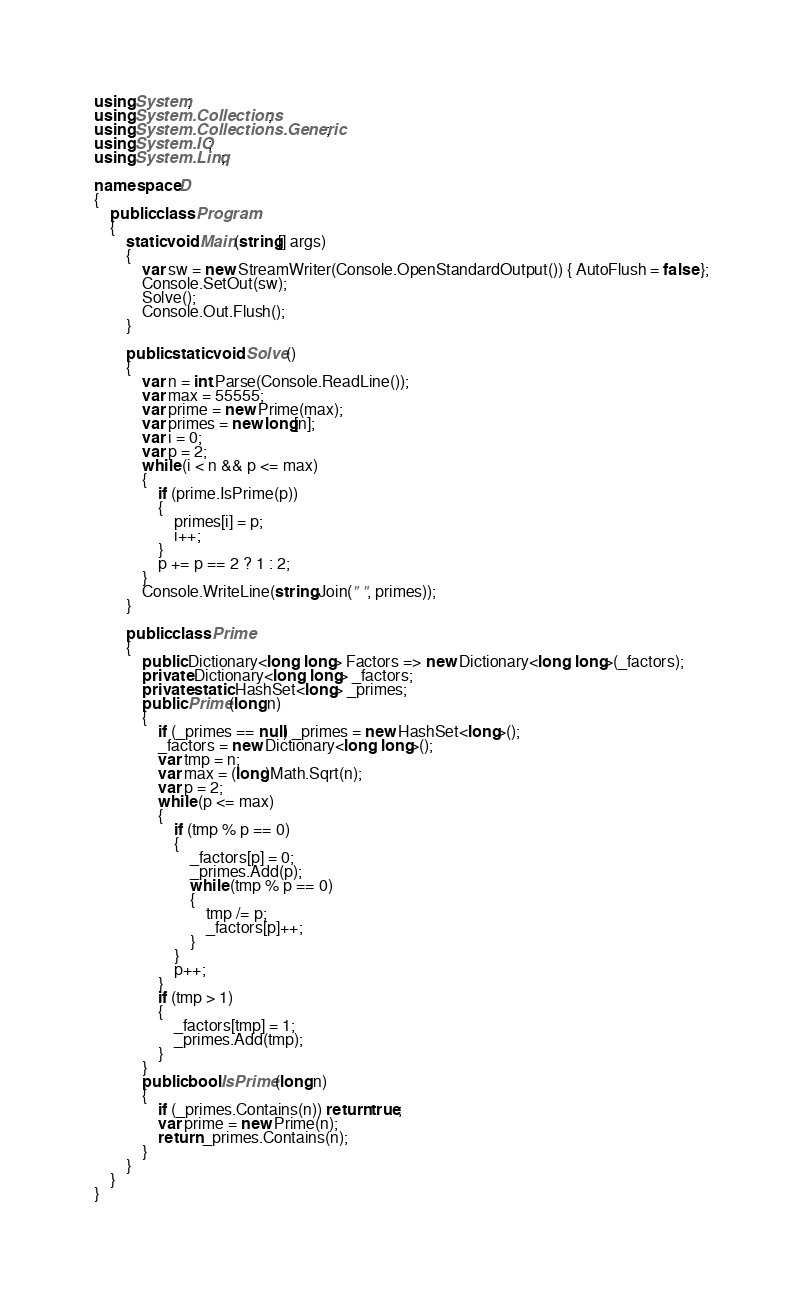<code> <loc_0><loc_0><loc_500><loc_500><_C#_>using System;
using System.Collections;
using System.Collections.Generic;
using System.IO;
using System.Linq;

namespace D
{
    public class Program
    {
        static void Main(string[] args)
        {
            var sw = new StreamWriter(Console.OpenStandardOutput()) { AutoFlush = false };
            Console.SetOut(sw);
            Solve();
            Console.Out.Flush();
        }

        public static void Solve()
        {
            var n = int.Parse(Console.ReadLine());
            var max = 55555;
            var prime = new Prime(max);
            var primes = new long[n];
            var i = 0;
            var p = 2;
            while (i < n && p <= max)
            {
                if (prime.IsPrime(p))
                {
                    primes[i] = p;
                    i++;
                }
                p += p == 2 ? 1 : 2;
            }
            Console.WriteLine(string.Join(" ", primes));
        }

        public class Prime
        {
            public Dictionary<long, long> Factors => new Dictionary<long, long>(_factors);
            private Dictionary<long, long> _factors;
            private static HashSet<long> _primes;
            public Prime(long n)
            {
                if (_primes == null) _primes = new HashSet<long>();
                _factors = new Dictionary<long, long>();
                var tmp = n;
                var max = (long)Math.Sqrt(n);
                var p = 2;
                while (p <= max)
                {
                    if (tmp % p == 0)
                    {
                        _factors[p] = 0;
                        _primes.Add(p);
                        while (tmp % p == 0)
                        {
                            tmp /= p;
                            _factors[p]++;
                        }
                    }
                    p++;
                }
                if (tmp > 1)
                {
                    _factors[tmp] = 1;
                    _primes.Add(tmp);
                }
            }
            public bool IsPrime(long n)
            {
                if (_primes.Contains(n)) return true;
                var prime = new Prime(n);
                return _primes.Contains(n);
            }
        }
    }
}
</code> 